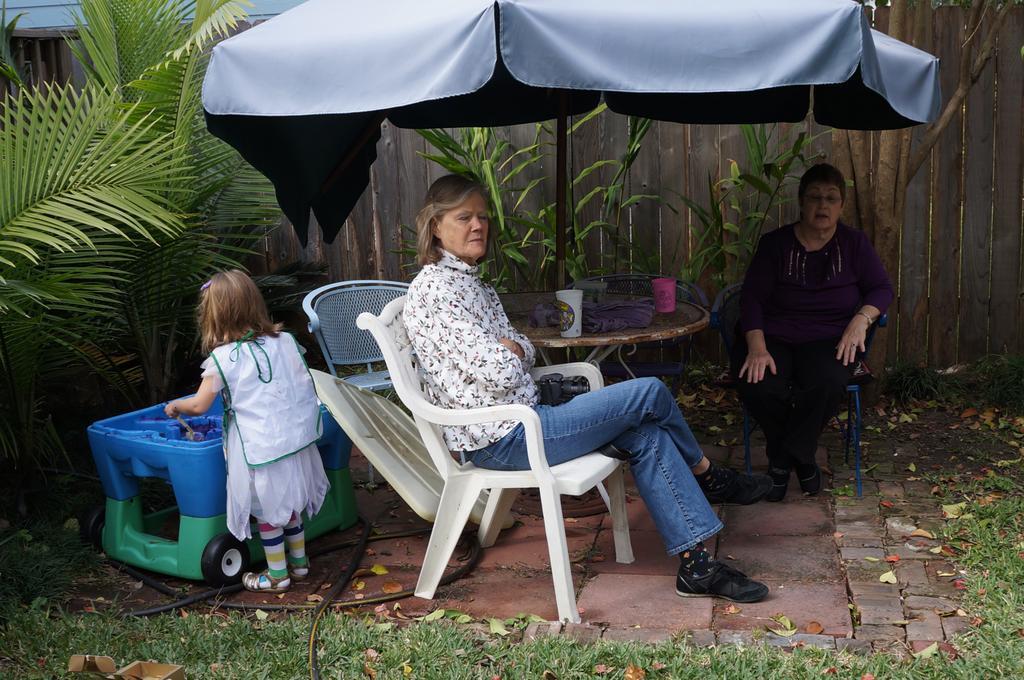Please provide a concise description of this image. This picture is taken in the garden. Two women are sitting on chairs under the table umbrella. The kid is playing beside them. The woman in the front wore a white shirt and blue jeans. There is a camera on her lap. there is a table and on it there are glasses and a cloth. In the background there is a wall. there are also plants, grass, dried leaves and a water pipe in the image.  